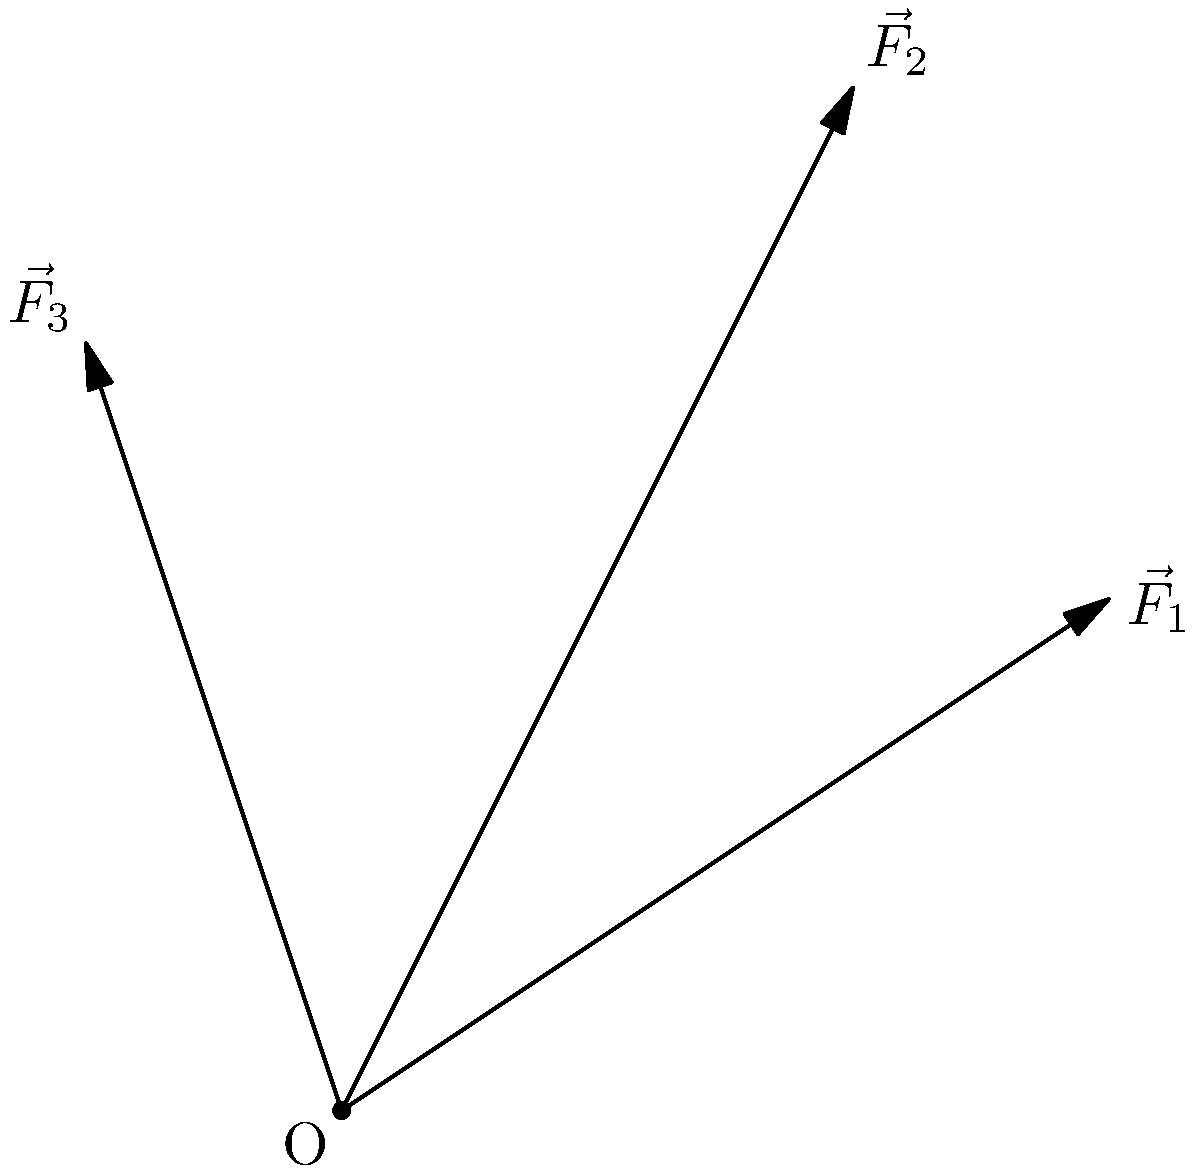In Lazio, Italy, three LGBTQ+ rights movements are exerting forces to push for policy changes. Movement 1 exerts a force $\vec{F}_1 = 3\hat{i} + 2\hat{j}$, Movement 2 exerts $\vec{F}_2 = 2\hat{i} + 4\hat{j}$, and Movement 3 exerts $\vec{F}_3 = -\hat{i} + 3\hat{j}$. What is the magnitude of the resultant force $\vec{R}$ of these three movements combined? To find the magnitude of the resultant force, we need to:

1. Add the three force vectors:
   $\vec{R} = \vec{F}_1 + \vec{F}_2 + \vec{F}_3$

2. Combine the components:
   $\vec{R} = (3\hat{i} + 2\hat{j}) + (2\hat{i} + 4\hat{j}) + (-\hat{i} + 3\hat{j})$
   $\vec{R} = (3 + 2 - 1)\hat{i} + (2 + 4 + 3)\hat{j}$
   $\vec{R} = 4\hat{i} + 9\hat{j}$

3. Calculate the magnitude using the Pythagorean theorem:
   $|\vec{R}| = \sqrt{R_x^2 + R_y^2}$
   $|\vec{R}| = \sqrt{4^2 + 9^2}$
   $|\vec{R}| = \sqrt{16 + 81}$
   $|\vec{R}| = \sqrt{97}$

Therefore, the magnitude of the resultant force is $\sqrt{97}$ units.
Answer: $\sqrt{97}$ units 